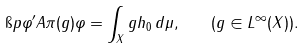<formula> <loc_0><loc_0><loc_500><loc_500>\i p { \varphi ^ { \prime } } { A \pi ( g ) \varphi } = \int _ { X } g h _ { 0 } \, d \mu , \quad ( g \in L ^ { \infty } ( X ) ) .</formula> 